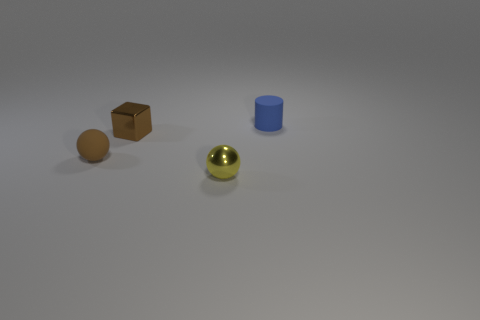Is there another purple cylinder made of the same material as the small cylinder?
Ensure brevity in your answer.  No. The tiny blue matte object is what shape?
Keep it short and to the point. Cylinder. What shape is the matte object that is right of the matte thing that is in front of the block?
Ensure brevity in your answer.  Cylinder. What number of other objects are the same shape as the brown metallic thing?
Ensure brevity in your answer.  0. What is the size of the yellow ball in front of the brown thing that is left of the small shiny block?
Offer a terse response. Small. Are there any tiny blue shiny cubes?
Provide a short and direct response. No. There is a matte thing on the left side of the blue matte cylinder; how many metallic objects are behind it?
Offer a very short reply. 1. The tiny matte object behind the brown metallic cube has what shape?
Keep it short and to the point. Cylinder. What material is the small thing that is in front of the rubber object that is left of the small blue rubber thing that is behind the metal cube?
Offer a very short reply. Metal. What number of other things are the same size as the rubber ball?
Ensure brevity in your answer.  3. 